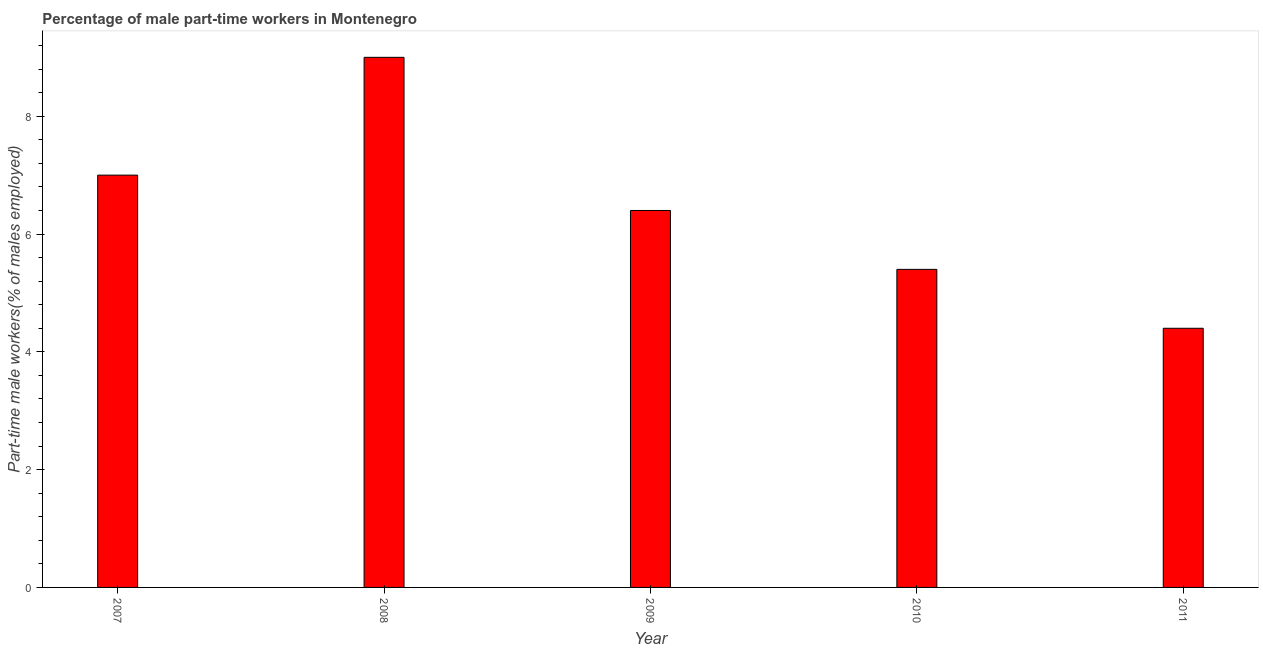Does the graph contain any zero values?
Your response must be concise. No. Does the graph contain grids?
Offer a very short reply. No. What is the title of the graph?
Provide a succinct answer. Percentage of male part-time workers in Montenegro. What is the label or title of the X-axis?
Your answer should be compact. Year. What is the label or title of the Y-axis?
Your response must be concise. Part-time male workers(% of males employed). What is the percentage of part-time male workers in 2009?
Give a very brief answer. 6.4. Across all years, what is the minimum percentage of part-time male workers?
Make the answer very short. 4.4. In which year was the percentage of part-time male workers maximum?
Provide a short and direct response. 2008. What is the sum of the percentage of part-time male workers?
Keep it short and to the point. 32.2. What is the difference between the percentage of part-time male workers in 2008 and 2010?
Provide a short and direct response. 3.6. What is the average percentage of part-time male workers per year?
Your answer should be compact. 6.44. What is the median percentage of part-time male workers?
Offer a very short reply. 6.4. What is the ratio of the percentage of part-time male workers in 2010 to that in 2011?
Offer a very short reply. 1.23. Is the percentage of part-time male workers in 2008 less than that in 2010?
Ensure brevity in your answer.  No. What is the difference between the highest and the second highest percentage of part-time male workers?
Offer a terse response. 2. Is the sum of the percentage of part-time male workers in 2010 and 2011 greater than the maximum percentage of part-time male workers across all years?
Provide a short and direct response. Yes. How many bars are there?
Your response must be concise. 5. Are all the bars in the graph horizontal?
Your response must be concise. No. What is the difference between two consecutive major ticks on the Y-axis?
Offer a terse response. 2. What is the Part-time male workers(% of males employed) in 2007?
Provide a short and direct response. 7. What is the Part-time male workers(% of males employed) in 2008?
Offer a terse response. 9. What is the Part-time male workers(% of males employed) of 2009?
Offer a terse response. 6.4. What is the Part-time male workers(% of males employed) of 2010?
Your answer should be compact. 5.4. What is the Part-time male workers(% of males employed) in 2011?
Keep it short and to the point. 4.4. What is the difference between the Part-time male workers(% of males employed) in 2007 and 2009?
Your answer should be compact. 0.6. What is the difference between the Part-time male workers(% of males employed) in 2007 and 2011?
Your response must be concise. 2.6. What is the difference between the Part-time male workers(% of males employed) in 2009 and 2010?
Provide a short and direct response. 1. What is the difference between the Part-time male workers(% of males employed) in 2009 and 2011?
Offer a terse response. 2. What is the difference between the Part-time male workers(% of males employed) in 2010 and 2011?
Provide a succinct answer. 1. What is the ratio of the Part-time male workers(% of males employed) in 2007 to that in 2008?
Offer a very short reply. 0.78. What is the ratio of the Part-time male workers(% of males employed) in 2007 to that in 2009?
Ensure brevity in your answer.  1.09. What is the ratio of the Part-time male workers(% of males employed) in 2007 to that in 2010?
Ensure brevity in your answer.  1.3. What is the ratio of the Part-time male workers(% of males employed) in 2007 to that in 2011?
Offer a very short reply. 1.59. What is the ratio of the Part-time male workers(% of males employed) in 2008 to that in 2009?
Offer a very short reply. 1.41. What is the ratio of the Part-time male workers(% of males employed) in 2008 to that in 2010?
Your answer should be compact. 1.67. What is the ratio of the Part-time male workers(% of males employed) in 2008 to that in 2011?
Give a very brief answer. 2.04. What is the ratio of the Part-time male workers(% of males employed) in 2009 to that in 2010?
Your response must be concise. 1.19. What is the ratio of the Part-time male workers(% of males employed) in 2009 to that in 2011?
Your answer should be compact. 1.46. What is the ratio of the Part-time male workers(% of males employed) in 2010 to that in 2011?
Your answer should be very brief. 1.23. 